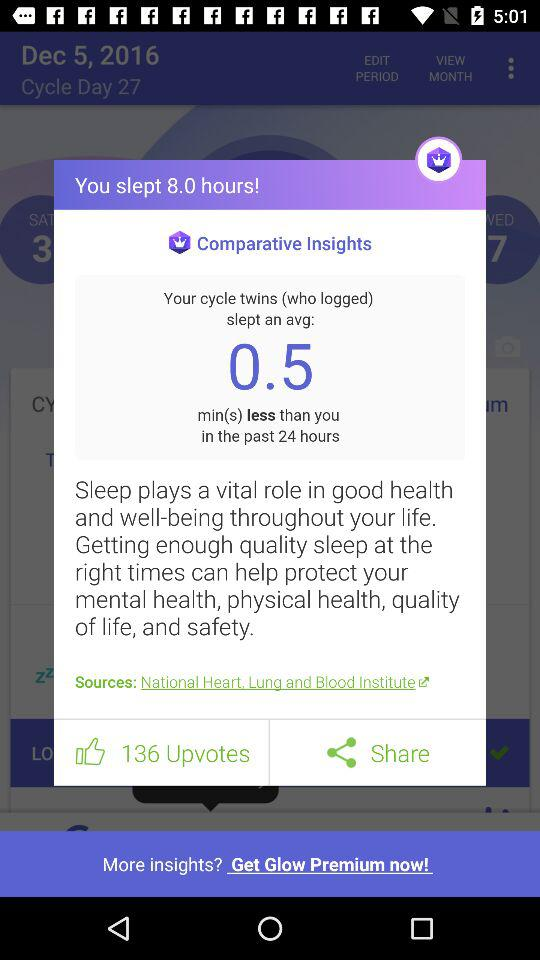For how many hours did I sleep? You slept for 8 hours. 